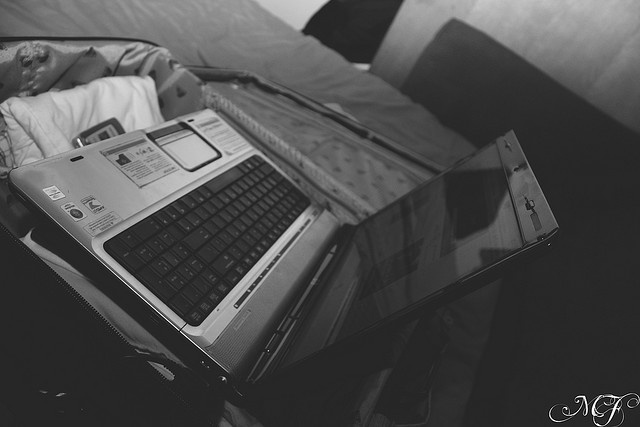Describe the objects in this image and their specific colors. I can see laptop in gray, black, darkgray, and lightgray tones, suitcase in gray, black, darkgray, and lightgray tones, bed in gray, black, and silver tones, and cell phone in gray, black, and lightgray tones in this image. 